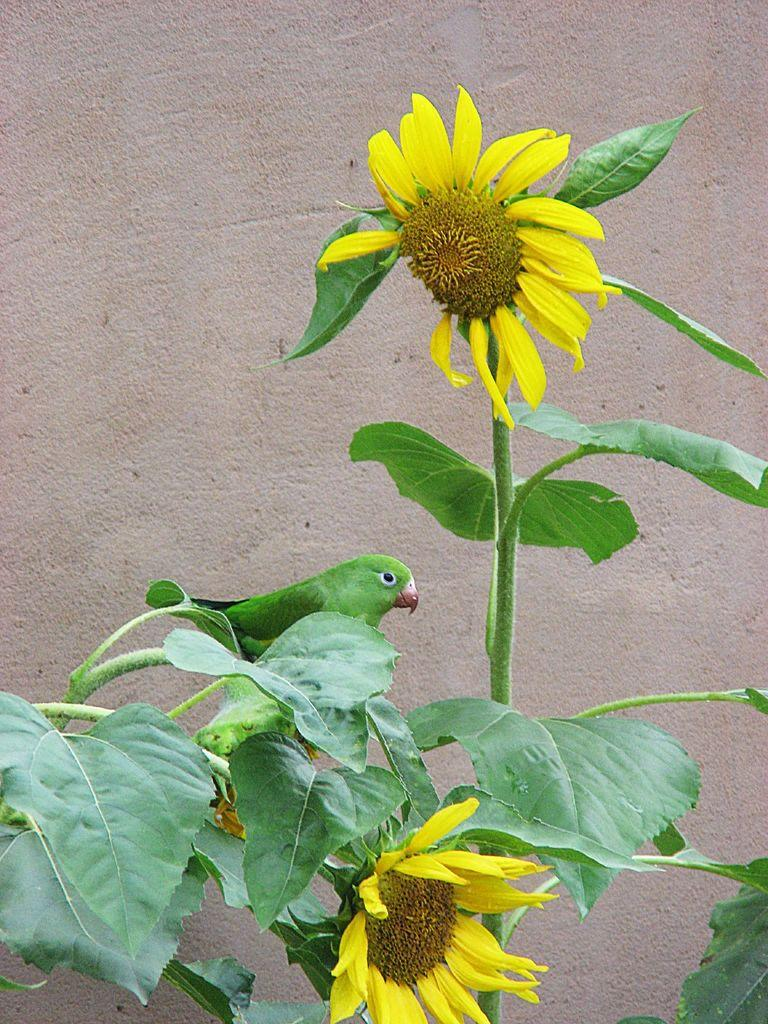What type of living organisms can be seen on the plant in the image? There are flowers on a plant in the image. What animal is sitting on a branch of the plant in the image? There is a bird sitting on a branch of a plant in the image. What can be seen in the background of the image? There is a wall visible in the background of the image. What color is the paint on the range in the image? There is no paint or range present in the image. 